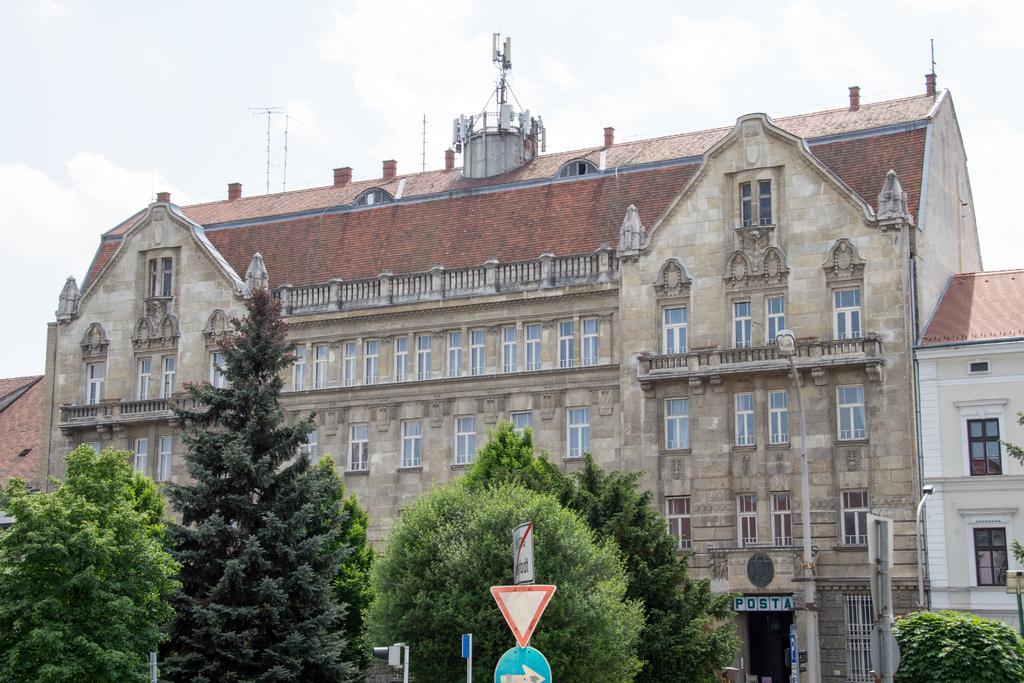Can you describe this image briefly? In this image in the center there are buildings trees, at the bottom there are poles and boards. And at the top of the building there are poles, antennas and at the top of the image there is sky. 